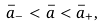Convert formula to latex. <formula><loc_0><loc_0><loc_500><loc_500>\bar { a } _ { - } < \bar { a } < \bar { a } _ { + } ,</formula> 